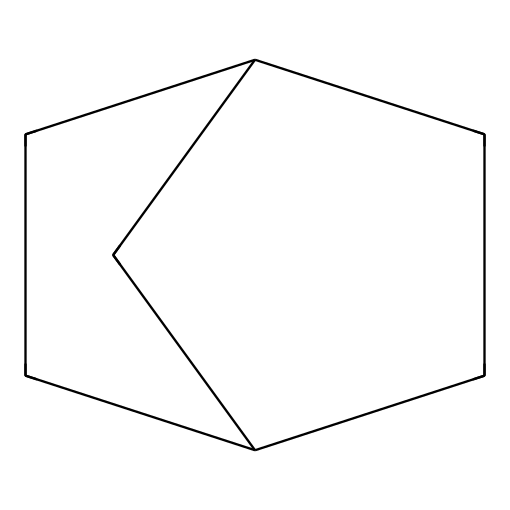What is the name of this chemical? The SMILES representation "C1CC2CCC1C2" corresponds to Bicyclo[2.2.1]heptane, as the structure indicates it contains two bridged cycloalkane rings.
Answer: Bicyclo[2.2.1]heptane How many carbon atoms are present in this molecule? The structure derived from the SMILES shows there are a total of 7 carbon atoms in the bicyclic arrangement, which can be counted visually or inferred from the representation.
Answer: 7 What type of bonding is predominantly present in Bicyclo[2.2.1]heptane? The molecule consists mostly of single covalent bonds between carbon atoms, typical of saturated hydrocarbons like cycloalkanes.
Answer: Single bonds How many distinct rings are present in Bicyclo[2.2.1]heptane? The "bicyclo" prefix indicates there are two interconnected rings in the structure, which is characteristic of bicyclic compounds.
Answer: 2 What is the bond angle around the carbon atoms in Bicyclo[2.2.1]heptane? In cycloalkanes, particularly Bicyclo[2.2.1]heptane, the bond angles are typically close to 109.5 degrees, reflecting sp3 hybridization in a tetrahedral arrangement.
Answer: Approximately 109.5 degrees What kind of isomerism can Bicyclo[2.2.1]heptane exhibit? Given its structure, Bicyclo[2.2.1]heptane can exhibit geometric isomerism, although limited due to the nature of its ring structure.
Answer: Geometric isomerism 